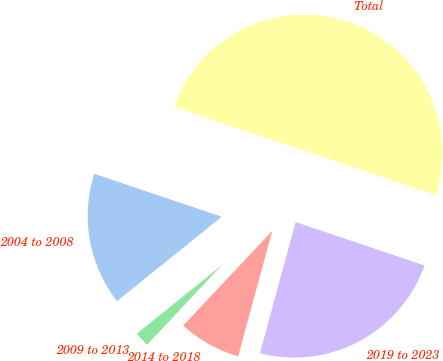Convert chart to OTSL. <chart><loc_0><loc_0><loc_500><loc_500><pie_chart><fcel>2004 to 2008<fcel>2009 to 2013<fcel>2014 to 2018<fcel>2019 to 2023<fcel>Total<nl><fcel>15.97%<fcel>2.2%<fcel>7.78%<fcel>24.05%<fcel>50.0%<nl></chart> 